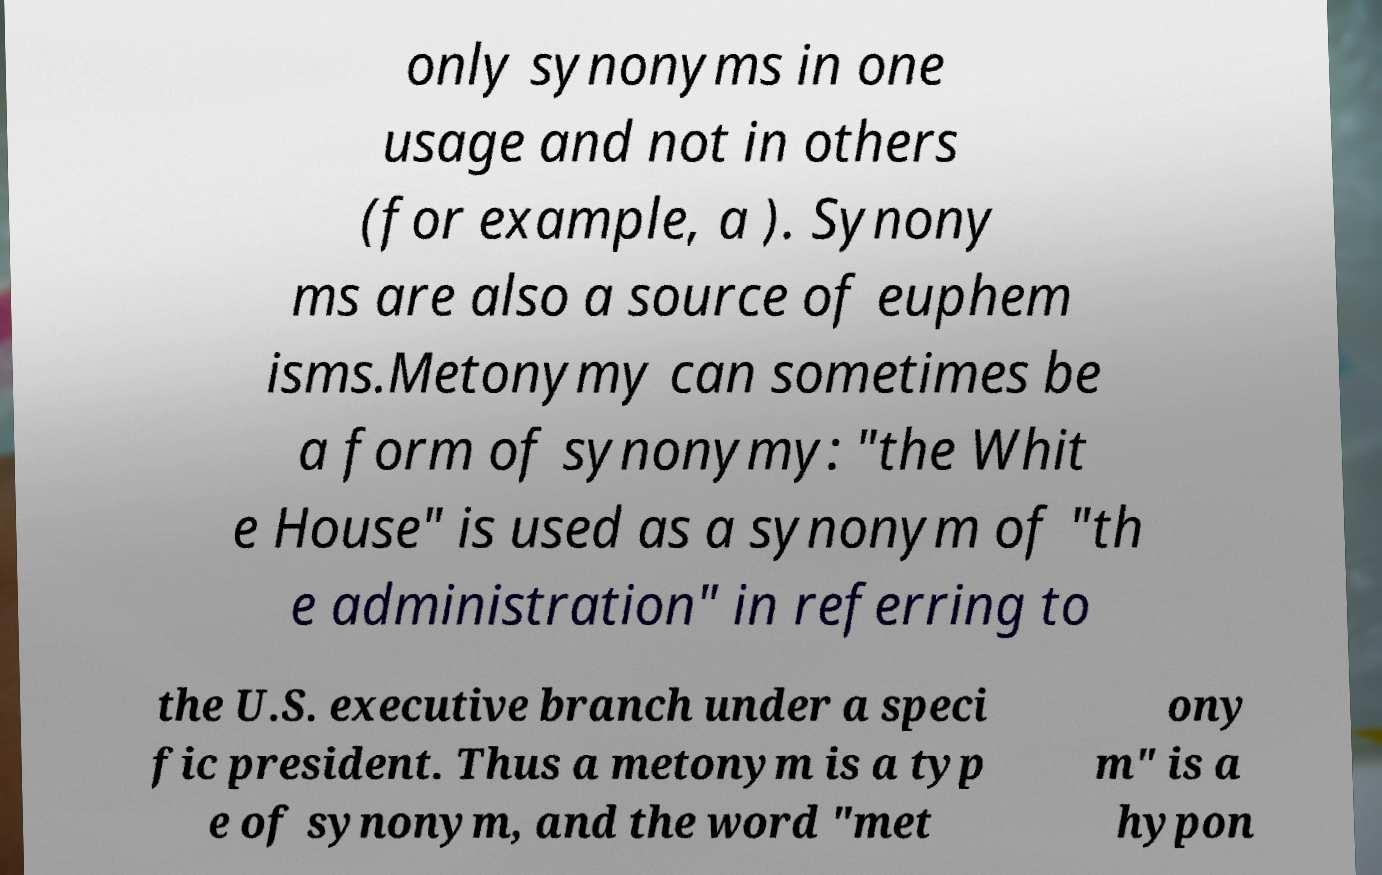Please identify and transcribe the text found in this image. only synonyms in one usage and not in others (for example, a ). Synony ms are also a source of euphem isms.Metonymy can sometimes be a form of synonymy: "the Whit e House" is used as a synonym of "th e administration" in referring to the U.S. executive branch under a speci fic president. Thus a metonym is a typ e of synonym, and the word "met ony m" is a hypon 